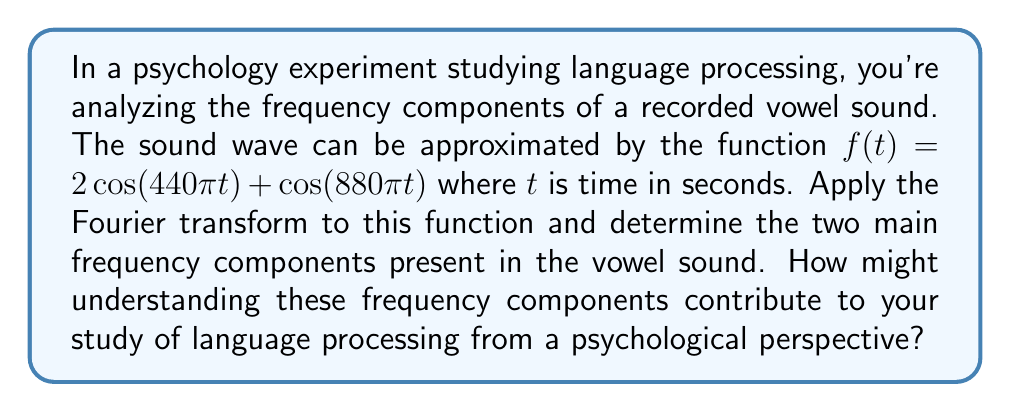Teach me how to tackle this problem. Let's approach this step-by-step:

1) The Fourier transform $F(\omega)$ of a function $f(t)$ is given by:

   $$F(\omega) = \int_{-\infty}^{\infty} f(t) e^{-i\omega t} dt$$

2) Our function is $f(t) = 2\cos(440\pi t) + \cos(880\pi t)$

3) We can use Euler's formula: $\cos(\theta) = \frac{1}{2}(e^{i\theta} + e^{-i\theta})$

4) Applying this to our function:

   $$f(t) = 2 \cdot \frac{1}{2}(e^{i440\pi t} + e^{-i440\pi t}) + \frac{1}{2}(e^{i880\pi t} + e^{-i880\pi t})$$

   $$f(t) = (e^{i440\pi t} + e^{-i440\pi t}) + \frac{1}{2}(e^{i880\pi t} + e^{-i880\pi t})$$

5) The Fourier transform of $e^{i\alpha t}$ is $2\pi \delta(\omega - \alpha)$, where $\delta$ is the Dirac delta function.

6) Applying the Fourier transform to our function:

   $$F(\omega) = 2\pi[\delta(\omega - 440\pi) + \delta(\omega + 440\pi)] + \pi[\delta(\omega - 880\pi) + \delta(\omega + 880\pi)]$$

7) This shows that the function has two main frequency components:
   - 440 Hz (corresponding to $\omega = 440\pi$)
   - 880 Hz (corresponding to $\omega = 880\pi$)

From a psychological perspective, understanding these frequency components can contribute to language processing studies in several ways:

1) These frequencies represent the fundamental frequency (440 Hz) and its first harmonic (880 Hz) of the vowel sound, which are crucial for vowel recognition and differentiation.

2) The relative amplitudes (2 for 440 Hz and 1 for 880 Hz) provide information about the timbre of the sound, which is important for speaker identification and emotional content in speech.

3) Analyzing these components can help in understanding how the human auditory system processes and interprets speech sounds, potentially leading to insights about language acquisition and processing.

4) This analysis could be extended to study differences in language processing between individuals or groups, or to investigate speech disorders.
Answer: The two main frequency components are 440 Hz and 880 Hz. Understanding these components can contribute to language processing studies by providing insights into vowel recognition, speaker identification, emotional content in speech, and the fundamental mechanisms of auditory processing in language comprehension. 